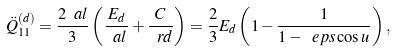<formula> <loc_0><loc_0><loc_500><loc_500>\ddot { Q } _ { 1 1 } ^ { ( d ) } = \frac { 2 \ a l } { 3 } \left ( \frac { E _ { d } } { \ a l } + \frac { C } { \ r d } \right ) = \frac { 2 } { 3 } E _ { d } \left ( 1 - \frac { 1 } { 1 - \ e p s \cos u } \right ) ,</formula> 